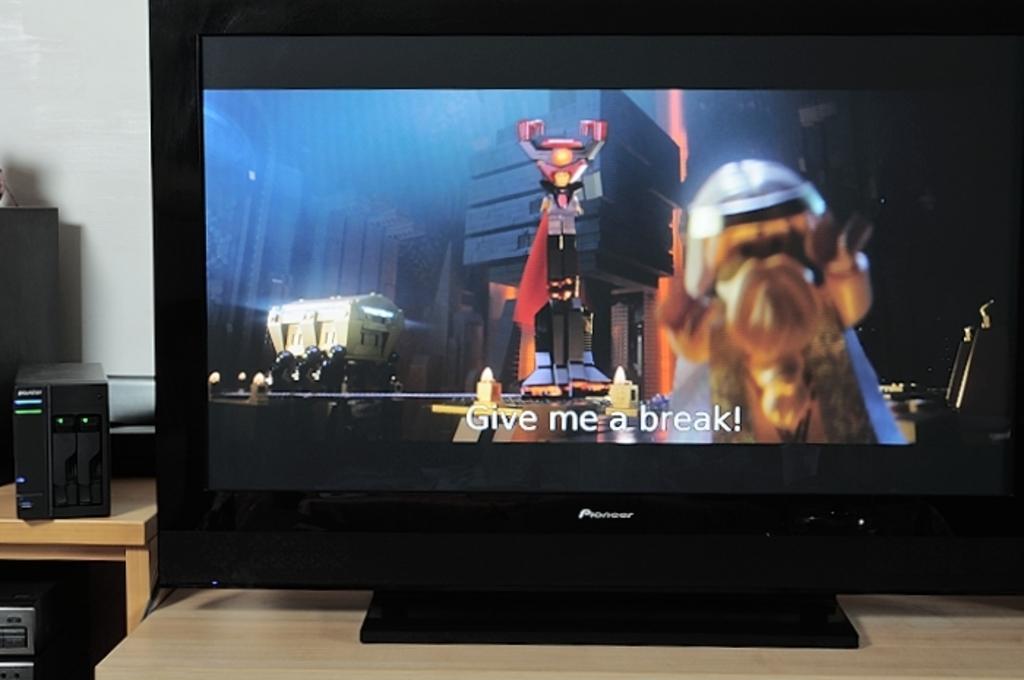Describe this image in one or two sentences. In this image, we can see a monitor on the stand and on the screen we can see some buildings, text and some cartoons and on the left, there are some boxes on the stand and there is a wall. 